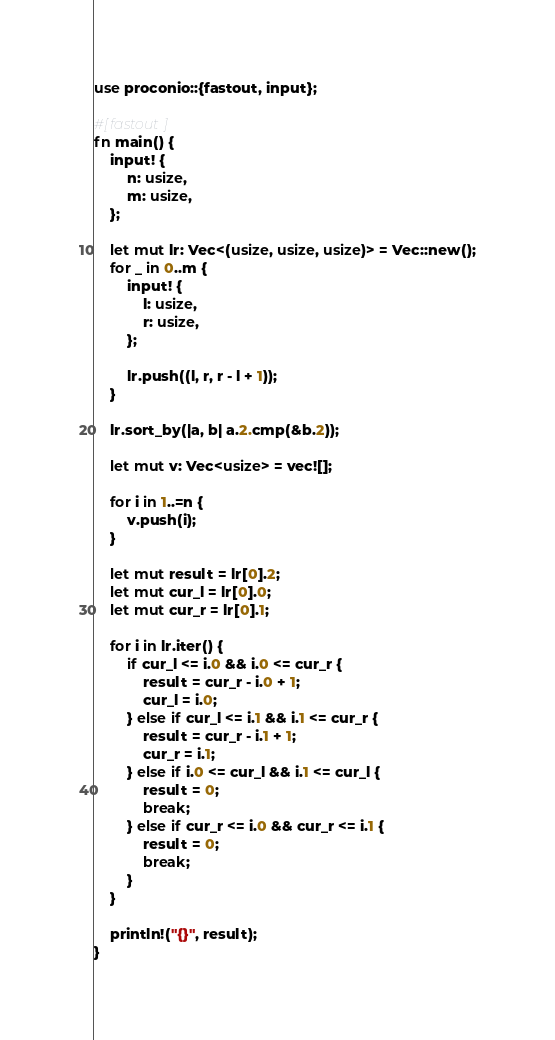<code> <loc_0><loc_0><loc_500><loc_500><_Rust_>use proconio::{fastout, input};

#[fastout]
fn main() {
    input! {
        n: usize,
        m: usize,
    };

    let mut lr: Vec<(usize, usize, usize)> = Vec::new();
    for _ in 0..m {
        input! {
            l: usize,
            r: usize,
        };

        lr.push((l, r, r - l + 1));
    }

    lr.sort_by(|a, b| a.2.cmp(&b.2));

    let mut v: Vec<usize> = vec![];

    for i in 1..=n {
        v.push(i);
    }

    let mut result = lr[0].2;
    let mut cur_l = lr[0].0;
    let mut cur_r = lr[0].1;

    for i in lr.iter() {
        if cur_l <= i.0 && i.0 <= cur_r {
            result = cur_r - i.0 + 1;
            cur_l = i.0;
        } else if cur_l <= i.1 && i.1 <= cur_r {
            result = cur_r - i.1 + 1;
            cur_r = i.1;
        } else if i.0 <= cur_l && i.1 <= cur_l {
            result = 0;
            break;
        } else if cur_r <= i.0 && cur_r <= i.1 {
            result = 0;
            break;
        }
    }

    println!("{}", result);
}
</code> 